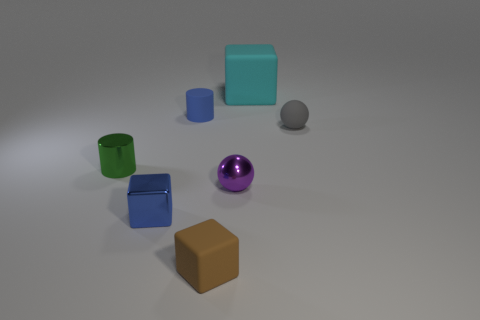How many other matte objects have the same size as the blue rubber object?
Your answer should be very brief. 2. Are there more gray rubber things that are in front of the tiny brown thing than purple shiny objects to the left of the blue matte cylinder?
Give a very brief answer. No. Are there any big cyan rubber objects of the same shape as the brown thing?
Provide a short and direct response. Yes. There is a blue thing that is to the left of the matte thing left of the small brown object; what size is it?
Give a very brief answer. Small. What shape is the tiny rubber object to the right of the rubber block that is in front of the rubber cube behind the brown object?
Your response must be concise. Sphere. What is the size of the cube that is the same material as the large thing?
Your response must be concise. Small. Is the number of small blue matte cubes greater than the number of green objects?
Make the answer very short. No. There is a blue cube that is the same size as the gray ball; what is its material?
Provide a succinct answer. Metal. Does the blue object that is behind the blue shiny thing have the same size as the blue block?
Give a very brief answer. Yes. What number of balls are small gray things or small blue things?
Your response must be concise. 1. 